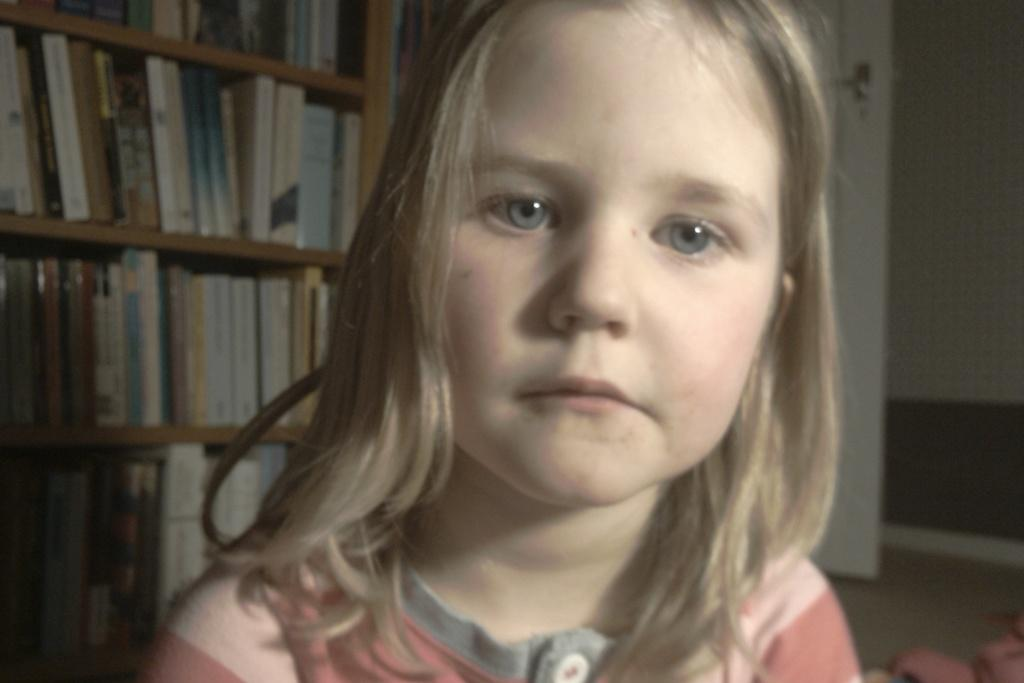Who is the main subject in the image? There is a girl in the center of the image. What can be seen in the background of the image? There are books arranged in shelves in the background of the image. Are there any boys playing on the grass in the image? There is no grass or boys present in the image; it only features a girl and books arranged in shelves. 